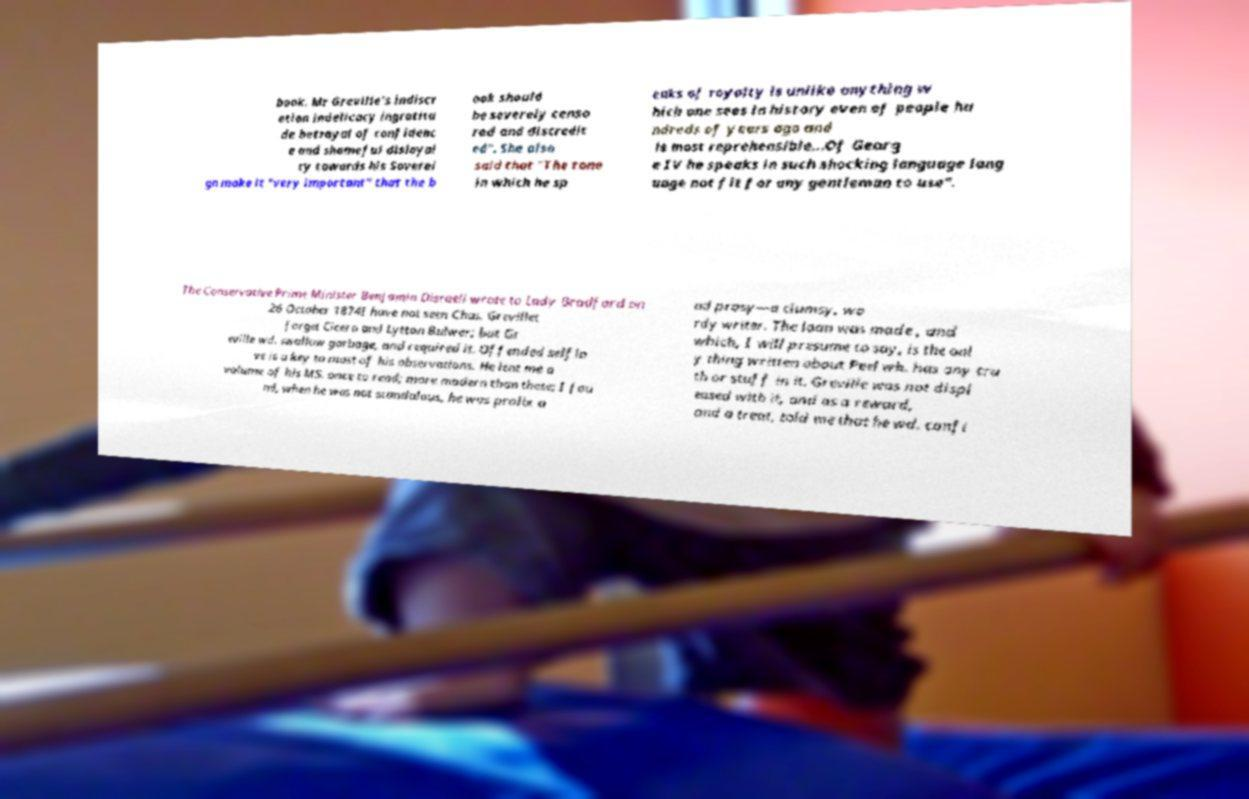Can you read and provide the text displayed in the image?This photo seems to have some interesting text. Can you extract and type it out for me? book. Mr Greville's indiscr etion indelicacy ingratitu de betrayal of confidenc e and shameful disloyal ty towards his Soverei gn make it "very important" that the b ook should be severely censo red and discredit ed". She also said that "The tone in which he sp eaks of royalty is unlike anything w hich one sees in history even of people hu ndreds of years ago and is most reprehensible...Of Georg e IV he speaks in such shocking language lang uage not fit for any gentleman to use". The Conservative Prime Minister Benjamin Disraeli wrote to Lady Bradford on 26 October 1874I have not seen Chas. Grevillet forget Cicero and Lytton Bulwer; but Gr eville wd. swallow garbage, and required it. Offended selflo ve is a key to most of his observations. He lent me a volume of his MS. once to read; more modern than these; I fou nd, when he was not scandalous, he was prolix a nd prosy—a clumsy, wo rdy writer. The loan was made , and which, I will presume to say, is the onl y thing written about Peel wh. has any tru th or stuff in it. Greville was not displ eased with it, and as a reward, and a treat, told me that he wd. confi 